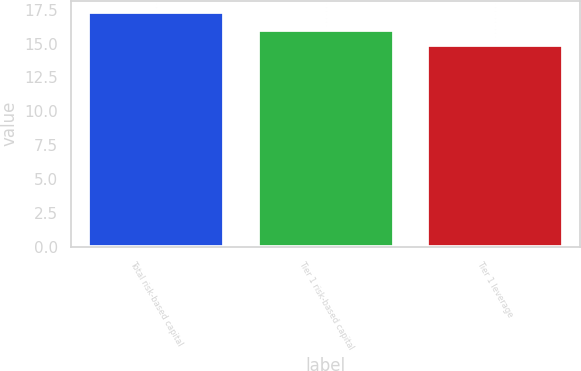Convert chart to OTSL. <chart><loc_0><loc_0><loc_500><loc_500><bar_chart><fcel>Total risk-based capital<fcel>Tier 1 risk-based capital<fcel>Tier 1 leverage<nl><fcel>17.3<fcel>16<fcel>14.9<nl></chart> 